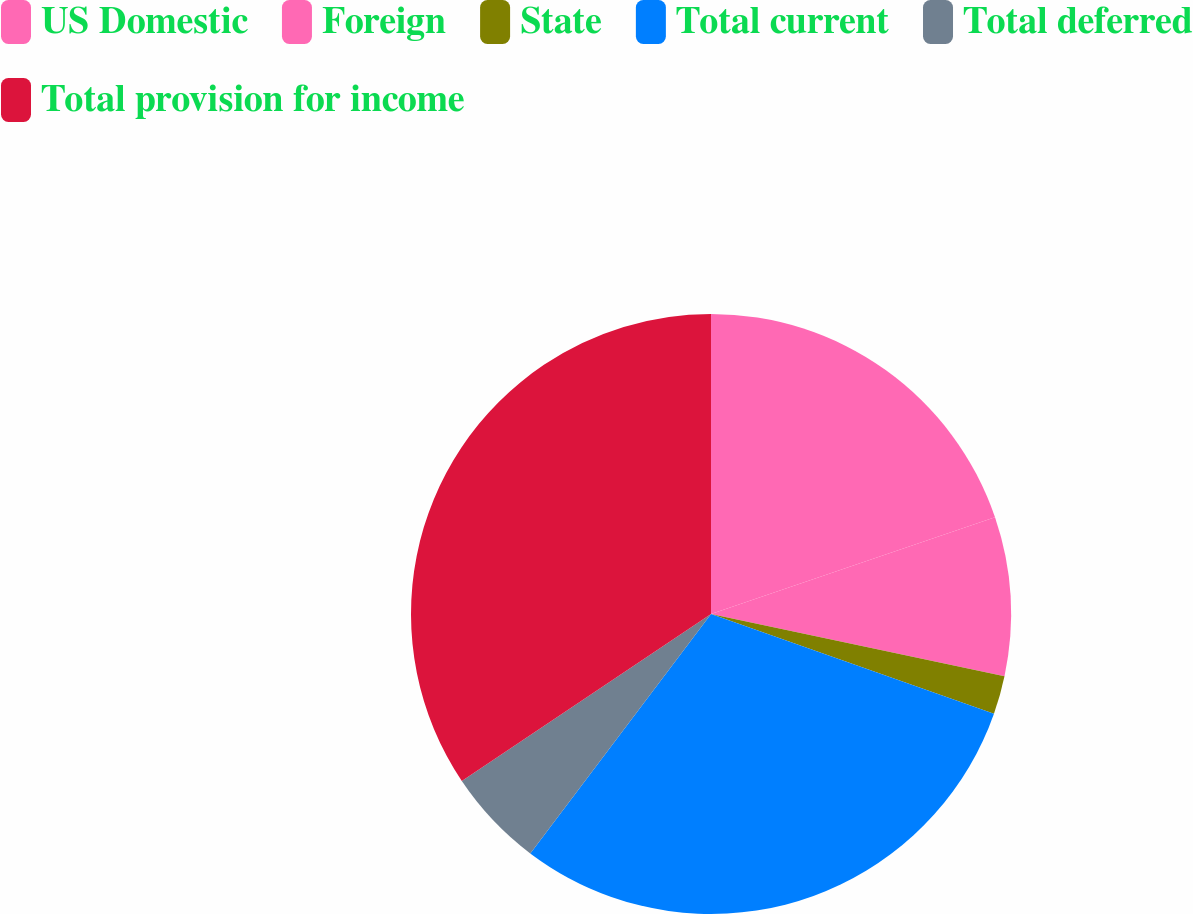<chart> <loc_0><loc_0><loc_500><loc_500><pie_chart><fcel>US Domestic<fcel>Foreign<fcel>State<fcel>Total current<fcel>Total deferred<fcel>Total provision for income<nl><fcel>19.78%<fcel>8.54%<fcel>2.07%<fcel>29.9%<fcel>5.31%<fcel>34.4%<nl></chart> 